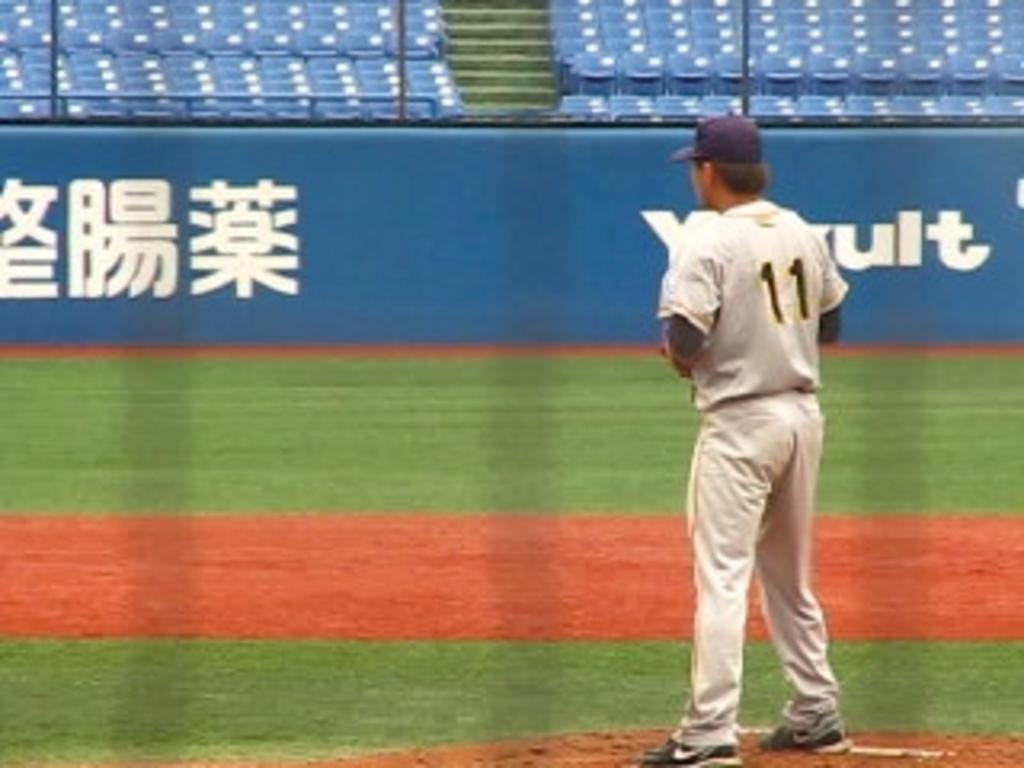<image>
Present a compact description of the photo's key features. Player number 11 stands in an empty stadium. 